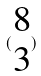<formula> <loc_0><loc_0><loc_500><loc_500>( \begin{matrix} 8 \\ 3 \end{matrix} )</formula> 